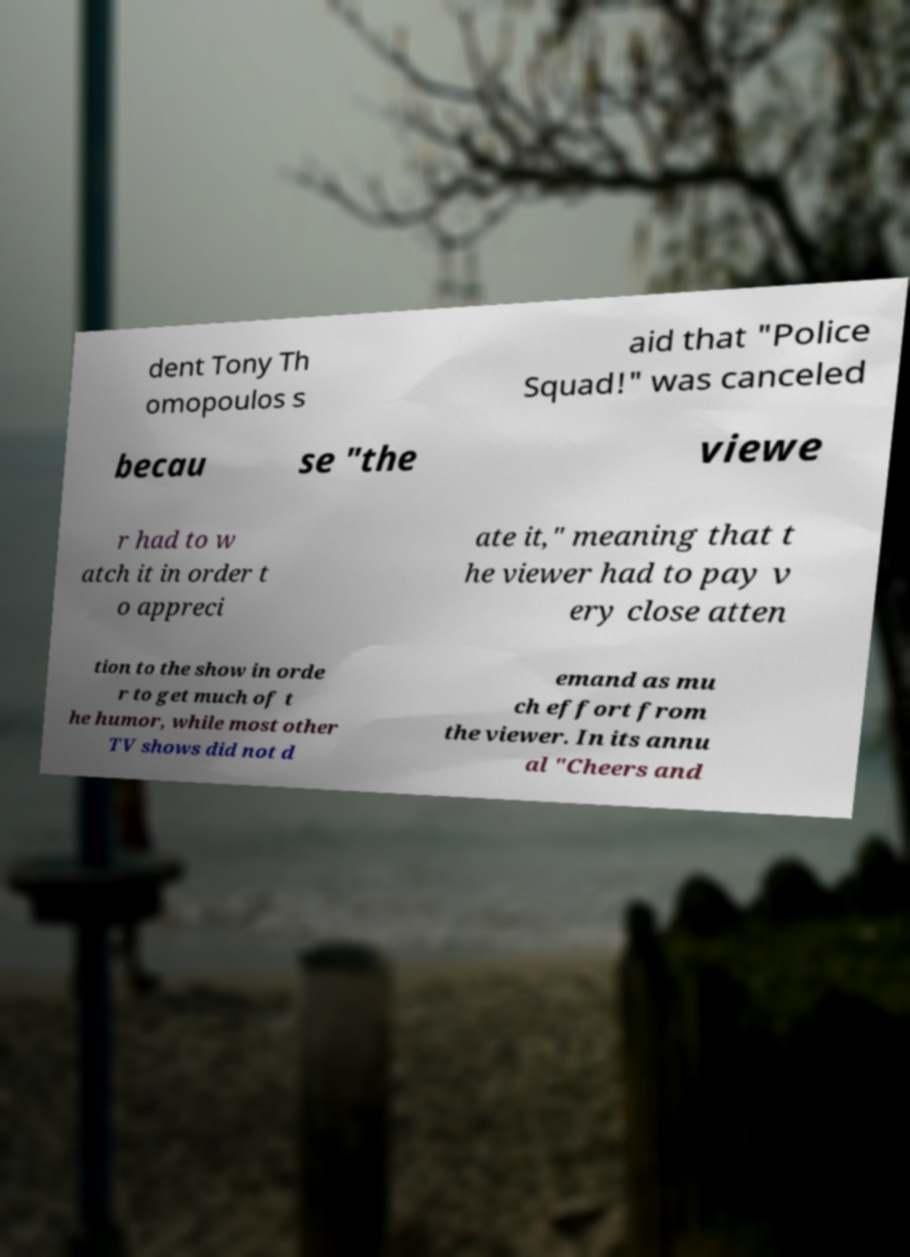Could you assist in decoding the text presented in this image and type it out clearly? dent Tony Th omopoulos s aid that "Police Squad!" was canceled becau se "the viewe r had to w atch it in order t o appreci ate it," meaning that t he viewer had to pay v ery close atten tion to the show in orde r to get much of t he humor, while most other TV shows did not d emand as mu ch effort from the viewer. In its annu al "Cheers and 